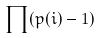Convert formula to latex. <formula><loc_0><loc_0><loc_500><loc_500>\prod ( p ( i ) - 1 )</formula> 